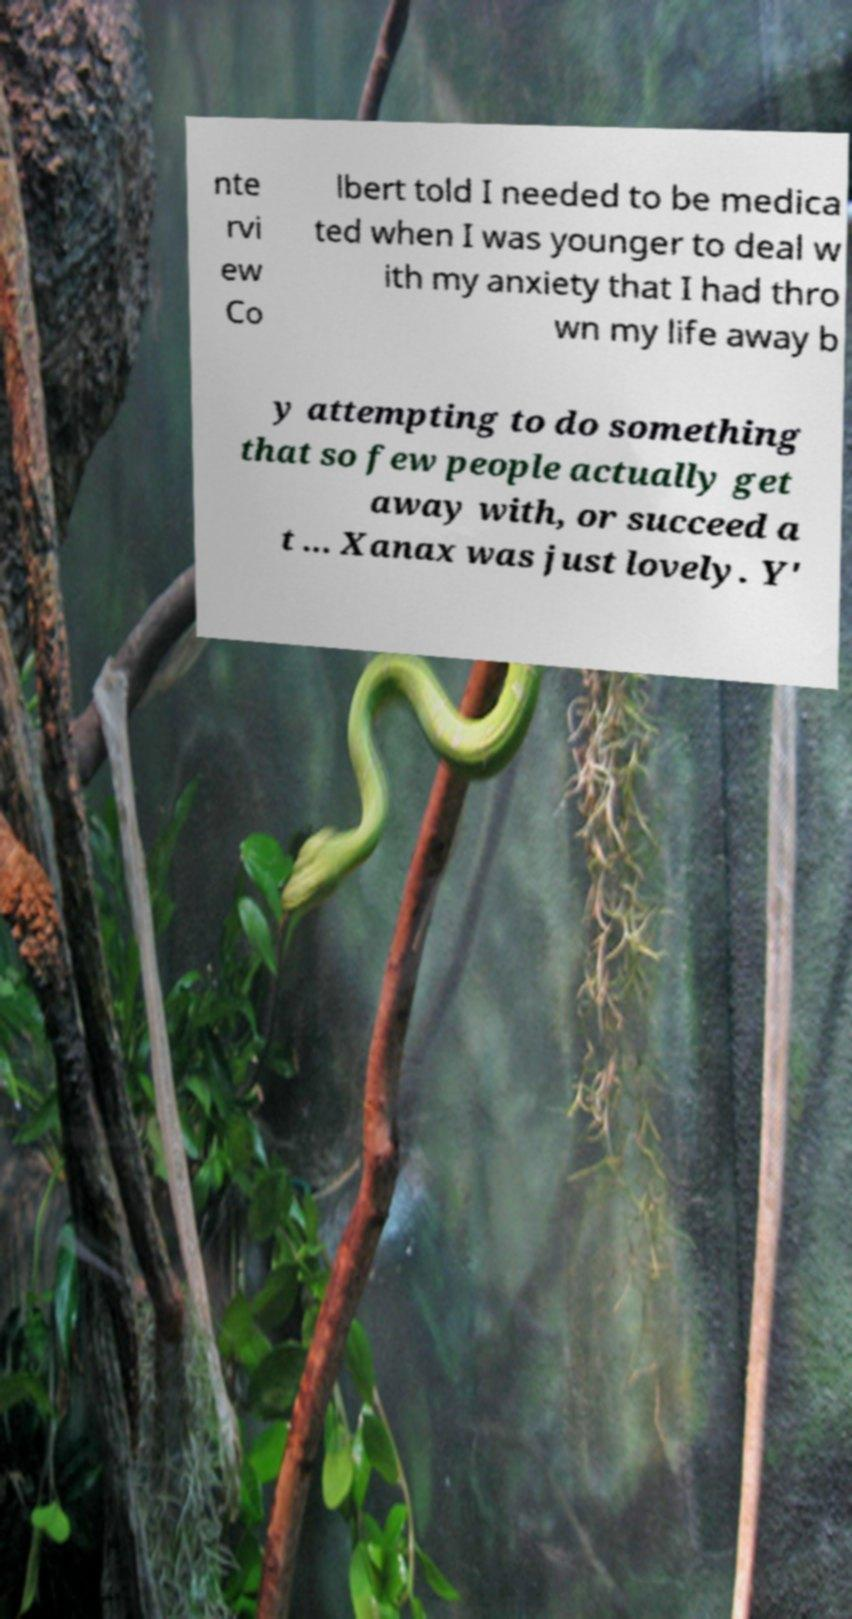Can you read and provide the text displayed in the image?This photo seems to have some interesting text. Can you extract and type it out for me? nte rvi ew Co lbert told I needed to be medica ted when I was younger to deal w ith my anxiety that I had thro wn my life away b y attempting to do something that so few people actually get away with, or succeed a t ... Xanax was just lovely. Y' 